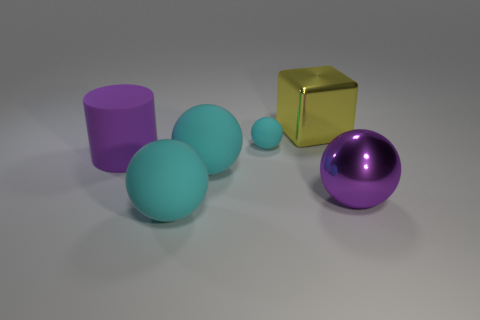Is the number of shiny blocks less than the number of brown balls?
Ensure brevity in your answer.  No. There is a large thing that is right of the small cyan object and on the left side of the big purple metallic sphere; what is its shape?
Make the answer very short. Cube. What number of big metal blocks are there?
Make the answer very short. 1. There is a purple object behind the sphere right of the large metal thing that is left of the metal sphere; what is its material?
Ensure brevity in your answer.  Rubber. How many matte balls are on the right side of the large cyan object in front of the big purple metallic object?
Keep it short and to the point. 2. There is a small matte object that is the same shape as the big purple shiny object; what color is it?
Provide a succinct answer. Cyan. Are the yellow object and the purple ball made of the same material?
Your answer should be compact. Yes. What number of balls are either matte things or big yellow things?
Make the answer very short. 3. How big is the matte object in front of the big shiny thing that is on the right side of the block that is to the right of the large purple matte cylinder?
Offer a terse response. Large. What is the size of the other metal thing that is the same shape as the tiny cyan thing?
Give a very brief answer. Large. 